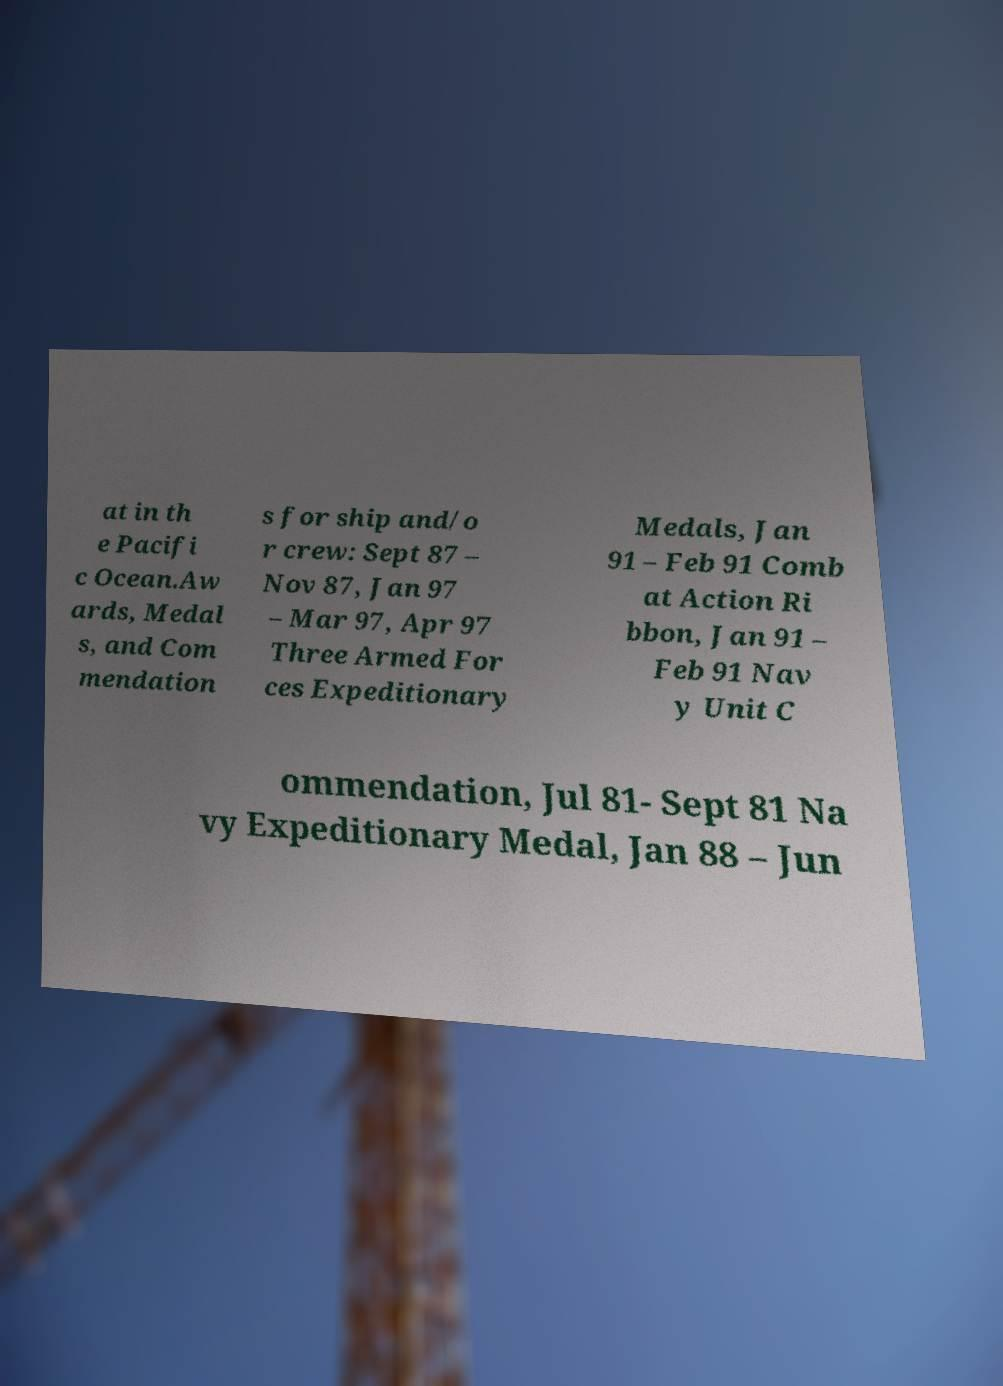What messages or text are displayed in this image? I need them in a readable, typed format. at in th e Pacifi c Ocean.Aw ards, Medal s, and Com mendation s for ship and/o r crew: Sept 87 – Nov 87, Jan 97 – Mar 97, Apr 97 Three Armed For ces Expeditionary Medals, Jan 91 – Feb 91 Comb at Action Ri bbon, Jan 91 – Feb 91 Nav y Unit C ommendation, Jul 81- Sept 81 Na vy Expeditionary Medal, Jan 88 – Jun 